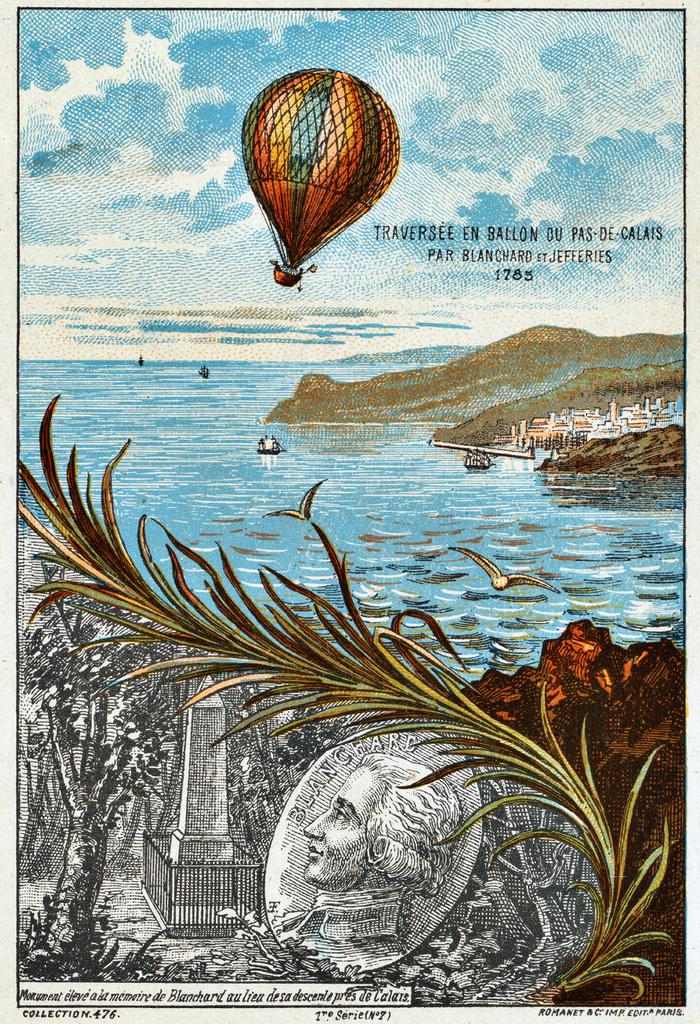What is depicted on the poster in the image? The poster contains a person's face, a plant, water, a paragliding scene, and a sky. What type of text is present on the poster? The poster contains some text. How many pies are shown in the paragliding scene on the poster? There are no pies present in the paragliding scene on the poster. 